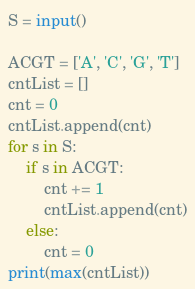Convert code to text. <code><loc_0><loc_0><loc_500><loc_500><_Python_>S = input()
 
ACGT = ['A', 'C', 'G', 'T']
cntList = []
cnt = 0
cntList.append(cnt)
for s in S:
    if s in ACGT:
        cnt += 1
        cntList.append(cnt)
    else:
        cnt = 0
print(max(cntList))</code> 